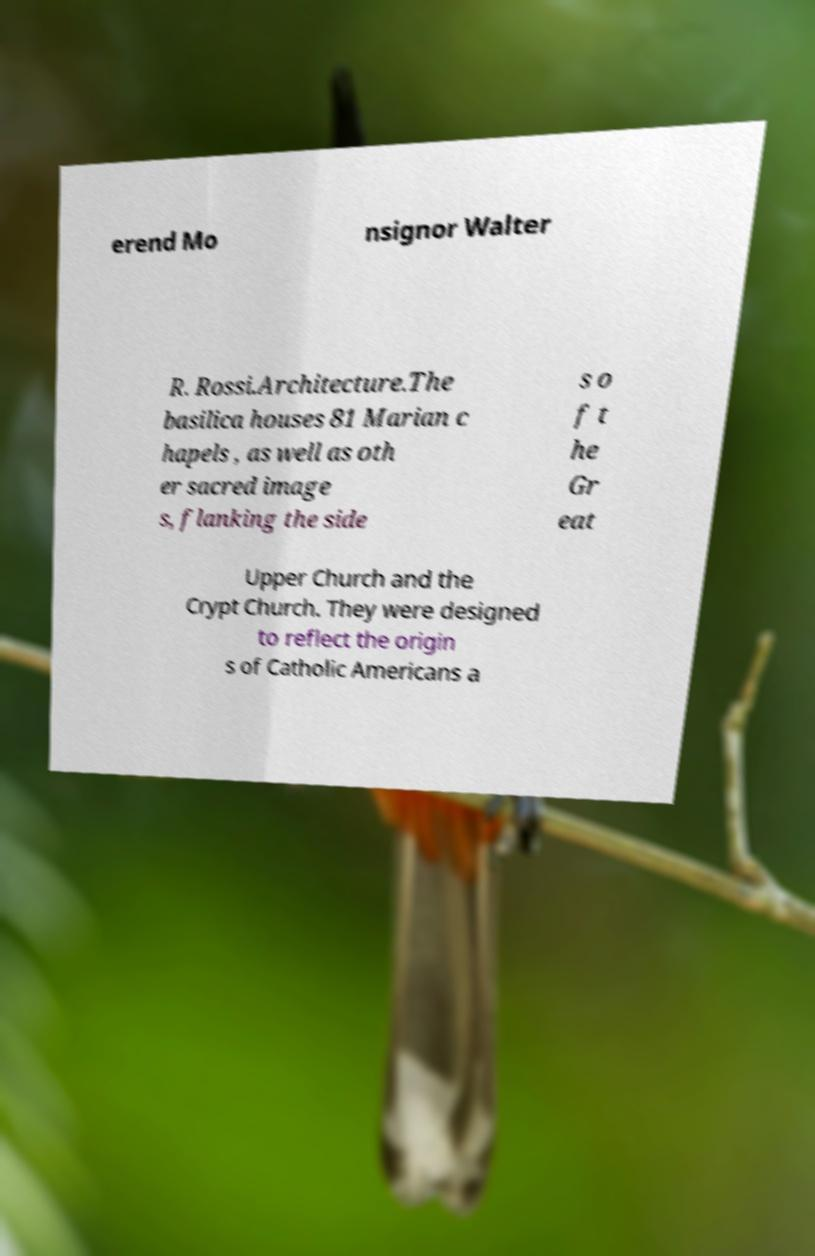There's text embedded in this image that I need extracted. Can you transcribe it verbatim? erend Mo nsignor Walter R. Rossi.Architecture.The basilica houses 81 Marian c hapels , as well as oth er sacred image s, flanking the side s o f t he Gr eat Upper Church and the Crypt Church. They were designed to reflect the origin s of Catholic Americans a 